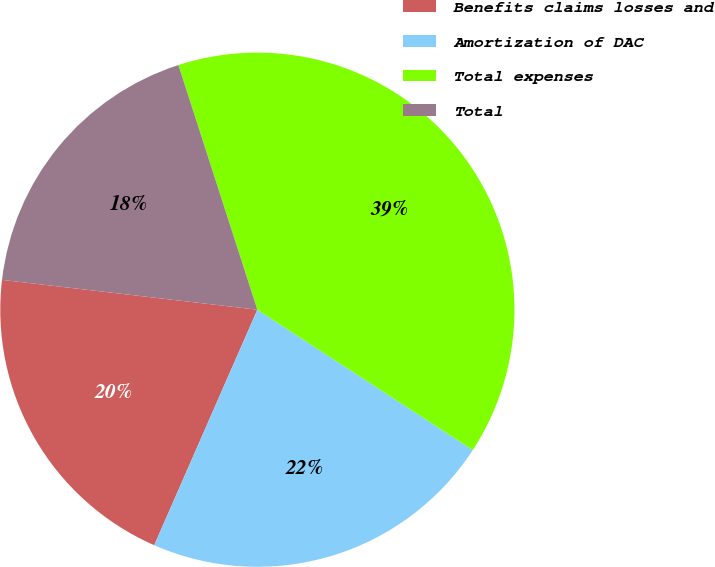Convert chart to OTSL. <chart><loc_0><loc_0><loc_500><loc_500><pie_chart><fcel>Benefits claims losses and<fcel>Amortization of DAC<fcel>Total expenses<fcel>Total<nl><fcel>20.28%<fcel>22.38%<fcel>39.16%<fcel>18.18%<nl></chart> 